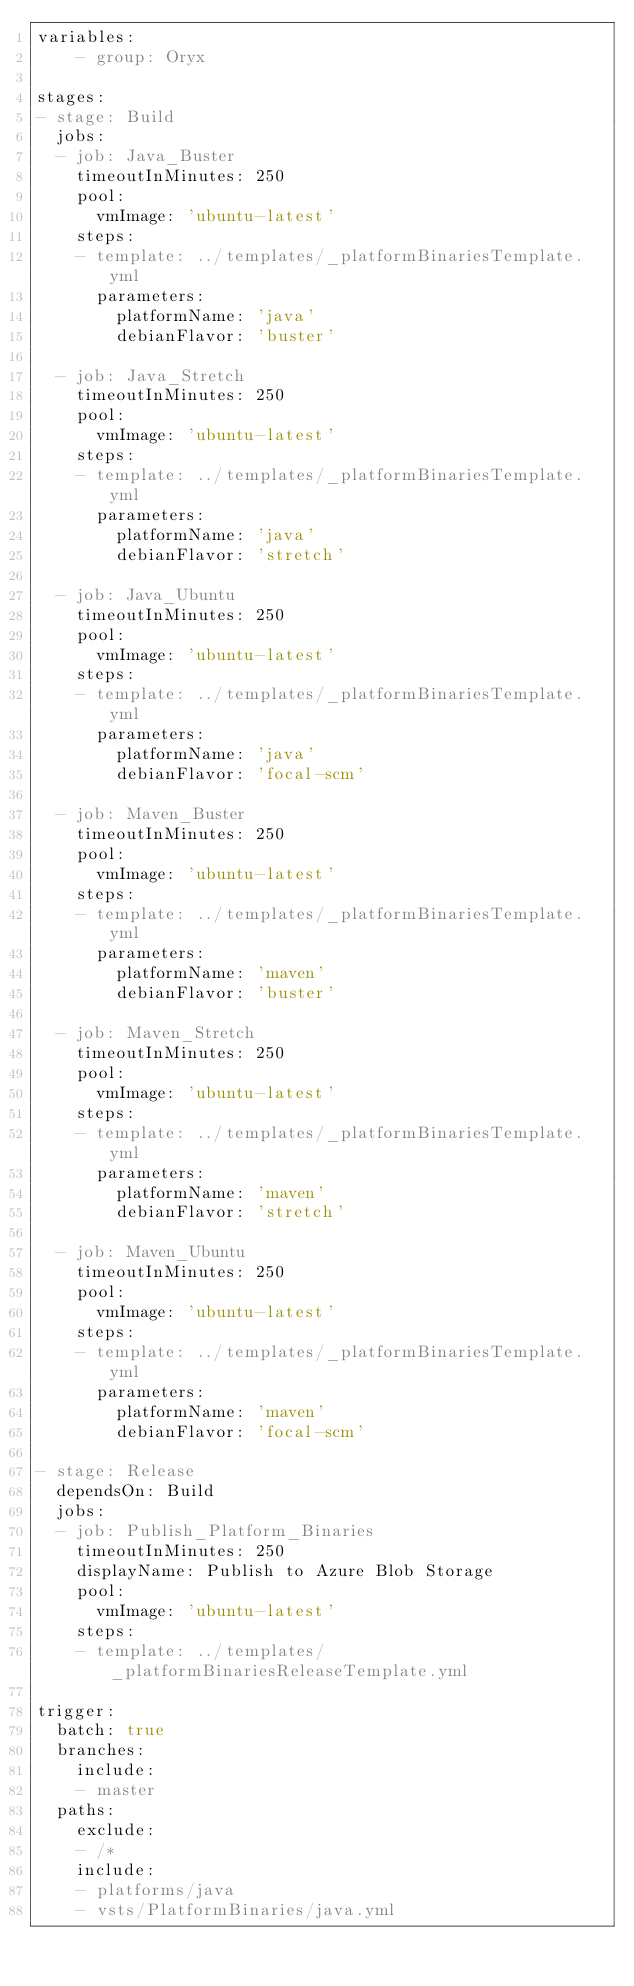<code> <loc_0><loc_0><loc_500><loc_500><_YAML_>variables:
    - group: Oryx
  
stages:
- stage: Build
  jobs:
  - job: Java_Buster
    timeoutInMinutes: 250
    pool:
      vmImage: 'ubuntu-latest'
    steps:
    - template: ../templates/_platformBinariesTemplate.yml
      parameters:
        platformName: 'java'
        debianFlavor: 'buster'

  - job: Java_Stretch
    timeoutInMinutes: 250
    pool:
      vmImage: 'ubuntu-latest'
    steps:
    - template: ../templates/_platformBinariesTemplate.yml
      parameters:
        platformName: 'java'
        debianFlavor: 'stretch'

  - job: Java_Ubuntu
    timeoutInMinutes: 250
    pool:
      vmImage: 'ubuntu-latest'
    steps:
    - template: ../templates/_platformBinariesTemplate.yml
      parameters:
        platformName: 'java'
        debianFlavor: 'focal-scm'

  - job: Maven_Buster
    timeoutInMinutes: 250
    pool:
      vmImage: 'ubuntu-latest'
    steps:
    - template: ../templates/_platformBinariesTemplate.yml
      parameters:
        platformName: 'maven'
        debianFlavor: 'buster'

  - job: Maven_Stretch
    timeoutInMinutes: 250
    pool:
      vmImage: 'ubuntu-latest'
    steps:
    - template: ../templates/_platformBinariesTemplate.yml
      parameters:
        platformName: 'maven'
        debianFlavor: 'stretch'

  - job: Maven_Ubuntu
    timeoutInMinutes: 250
    pool:
      vmImage: 'ubuntu-latest'
    steps:
    - template: ../templates/_platformBinariesTemplate.yml
      parameters:
        platformName: 'maven'
        debianFlavor: 'focal-scm'

- stage: Release
  dependsOn: Build
  jobs:
  - job: Publish_Platform_Binaries
    timeoutInMinutes: 250
    displayName: Publish to Azure Blob Storage
    pool:
      vmImage: 'ubuntu-latest'
    steps:
    - template: ../templates/_platformBinariesReleaseTemplate.yml

trigger:
  batch: true
  branches:
    include:
    - master
  paths:
    exclude:
    - /*
    include:
    - platforms/java
    - vsts/PlatformBinaries/java.yml</code> 